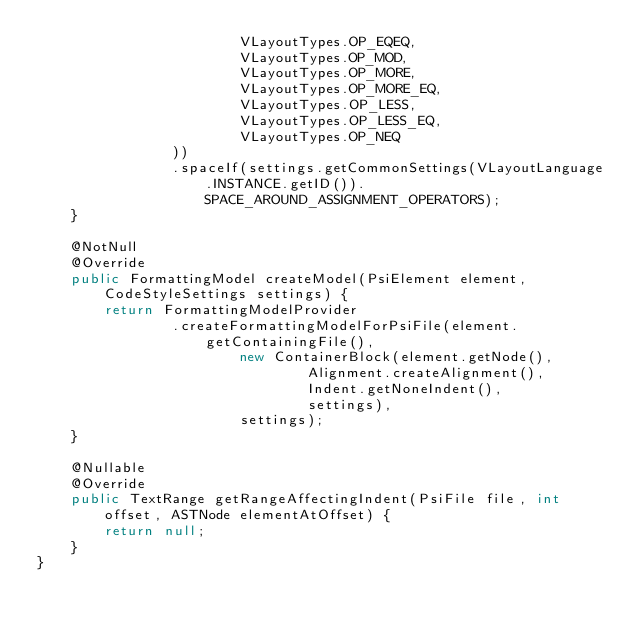<code> <loc_0><loc_0><loc_500><loc_500><_Java_>                        VLayoutTypes.OP_EQEQ,
                        VLayoutTypes.OP_MOD,
                        VLayoutTypes.OP_MORE,
                        VLayoutTypes.OP_MORE_EQ,
                        VLayoutTypes.OP_LESS,
                        VLayoutTypes.OP_LESS_EQ,
                        VLayoutTypes.OP_NEQ
                ))
                .spaceIf(settings.getCommonSettings(VLayoutLanguage.INSTANCE.getID()).SPACE_AROUND_ASSIGNMENT_OPERATORS);
    }

    @NotNull
    @Override
    public FormattingModel createModel(PsiElement element, CodeStyleSettings settings) {
        return FormattingModelProvider
                .createFormattingModelForPsiFile(element.getContainingFile(),
                        new ContainerBlock(element.getNode(),
                                Alignment.createAlignment(),
                                Indent.getNoneIndent(),
                                settings),
                        settings);
    }

    @Nullable
    @Override
    public TextRange getRangeAffectingIndent(PsiFile file, int offset, ASTNode elementAtOffset) {
        return null;
    }
}
</code> 